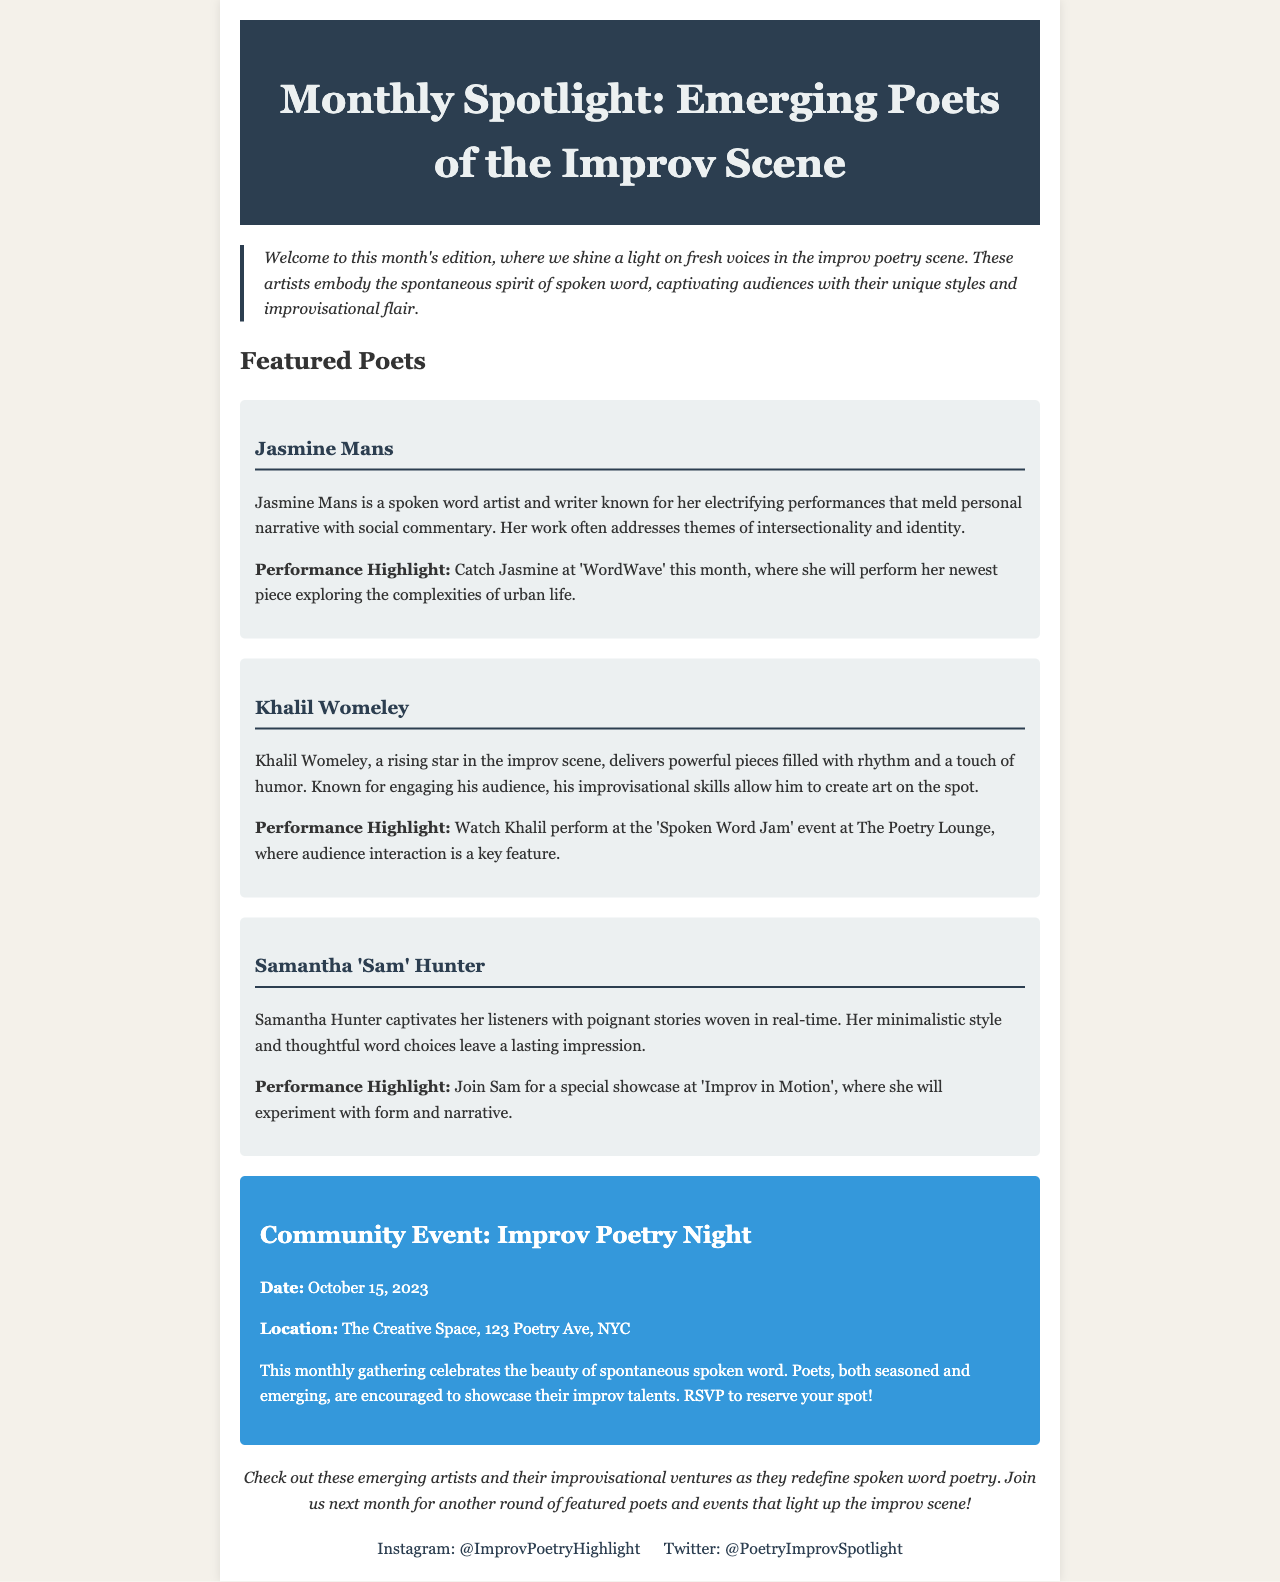What is the title of the newsletter? The title of the newsletter can be found at the top of the document in the header section.
Answer: Monthly Spotlight: Emerging Poets of the Improv Scene Who is one of the featured poets? The document lists several poets under the Featured Poets section, making it easy to identify names.
Answer: Jasmine Mans What is the date of the Community Event? The date is mentioned in the event section of the document, clearly labeled.
Answer: October 15, 2023 What venue is hosting the Improv Poetry Night? The venue is specified in the location part of the Community Event section.
Answer: The Creative Space What theme does Jasmine Mans address in her work? The themes of Jasmine Mans's work are discussed under her section.
Answer: Intersectionality and identity What type of performance will Khalil Womeley do? The performance type is highlighted in the description of Khalil Womeley's section.
Answer: Audience interaction What is the name of the event where Sam Hunter will perform? The event name can be found under the performance highlight section for Sam Hunter.
Answer: Improv in Motion What is the social media platform mentioned for Instagram? The social media links at the bottom provide details about their respective platforms.
Answer: Instagram 